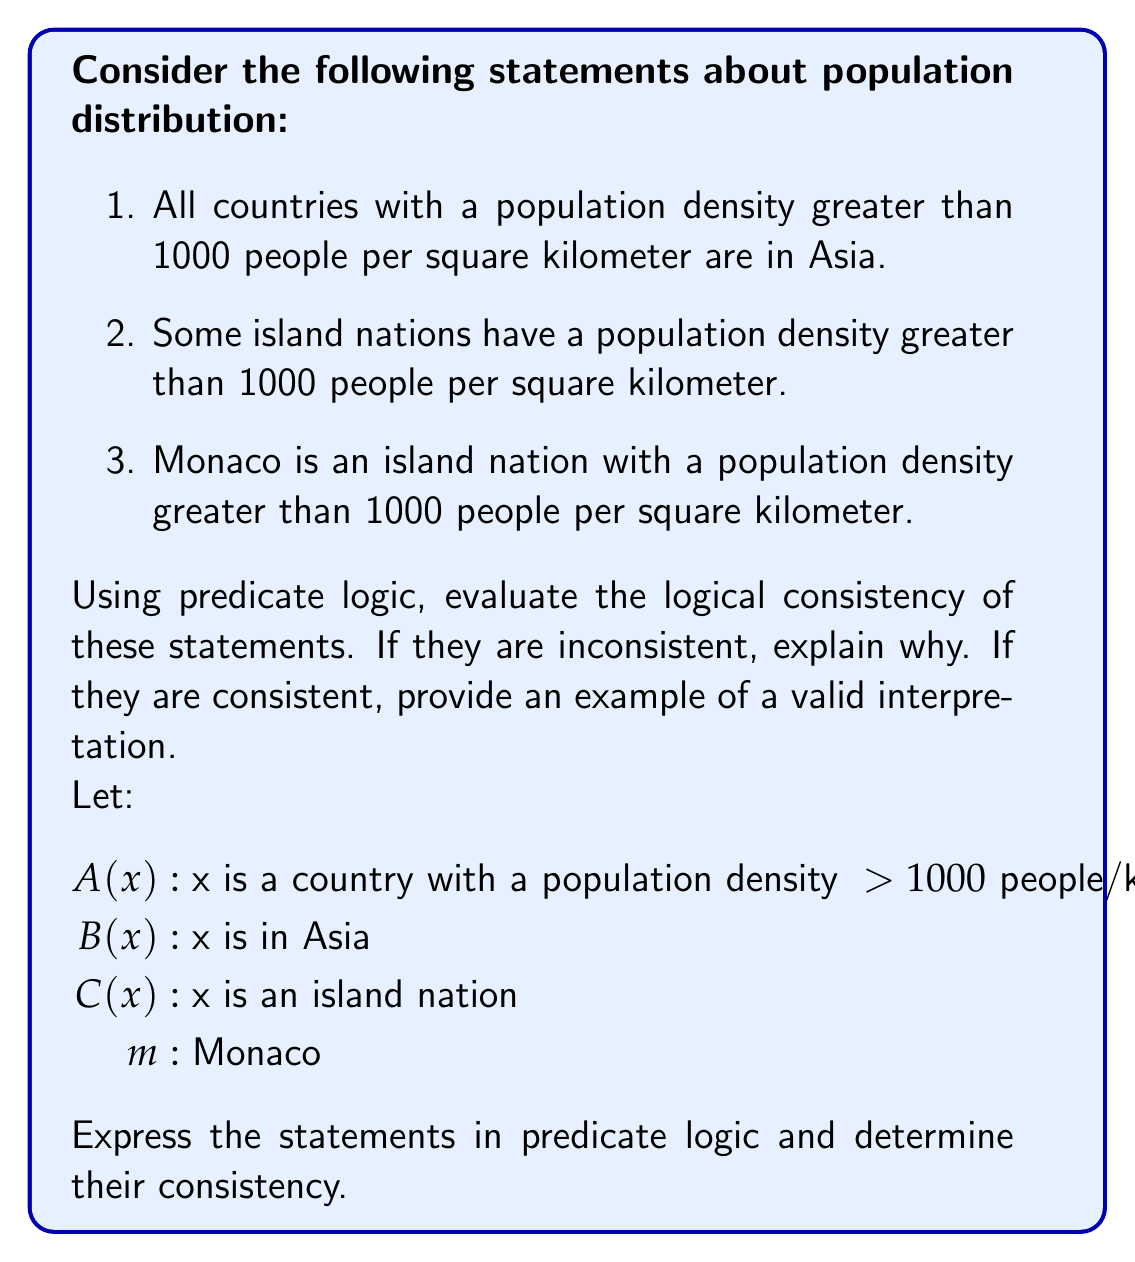Help me with this question. Let's express the given statements in predicate logic:

1. $\forall x(A(x) \rightarrow B(x))$
2. $\exists x(C(x) \land A(x))$
3. $C(m) \land A(m)$

To evaluate the consistency of these statements, we need to determine if there exists an interpretation that satisfies all three statements simultaneously.

Step 1: Analyze statement 1
Statement 1 claims that all countries with high population density are in Asia. This doesn't exclude the possibility of island nations or non-Asian countries having high population density.

Step 2: Analyze statement 2
Statement 2 asserts the existence of at least one island nation with high population density. This doesn't conflict with statement 1, as it doesn't specify the location of this island nation.

Step 3: Analyze statement 3
Statement 3 provides a specific example: Monaco. It states that Monaco is an island nation with high population density. However, Monaco is not in Asia (it's in Europe).

Step 4: Evaluate consistency
The statements are inconsistent because:
- Statement 1 implies that all countries with high population density (including Monaco) must be in Asia.
- Statement 3 states that Monaco has high population density but is not in Asia (since we know Monaco is in Europe).

This creates a contradiction between statements 1 and 3.

To make the statements consistent, we would need to modify statement 1 to allow for exceptions or change the facts about Monaco's location or population density.
Answer: The statements are logically inconsistent. The inconsistency arises from the contradiction between statement 1, which implies all high-density countries are in Asia, and statement 3, which provides a specific example (Monaco) of a high-density country that is not in Asia. 